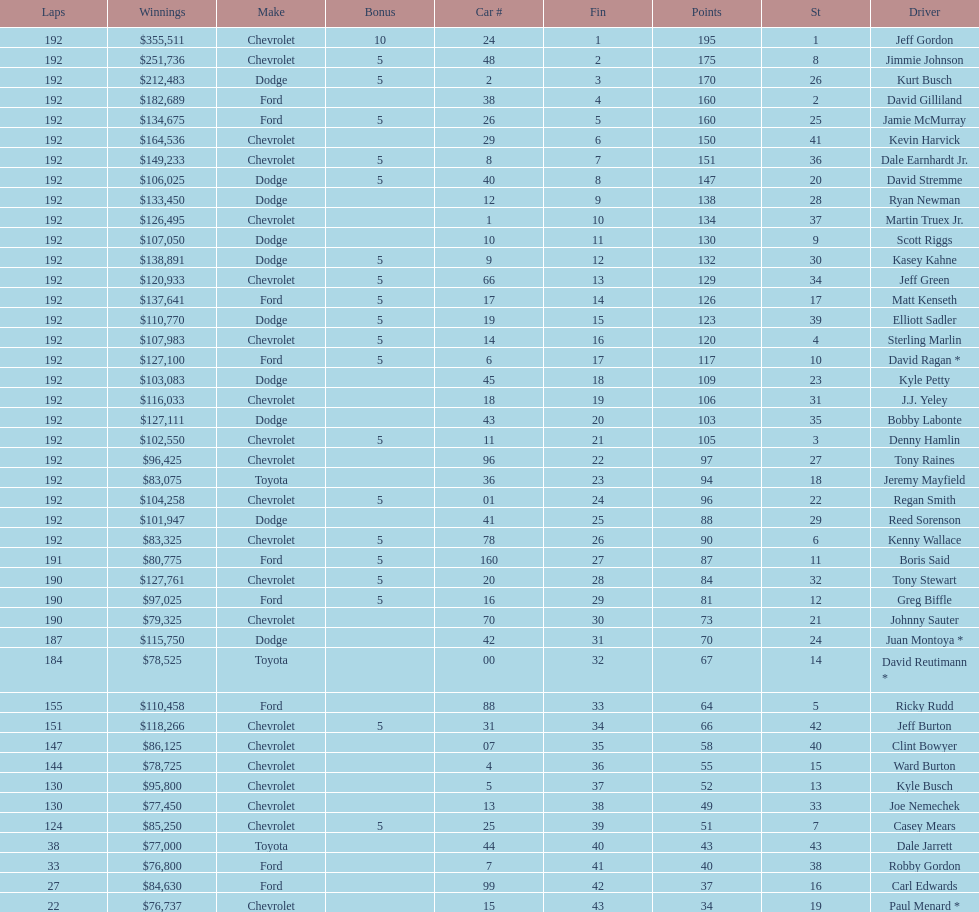What make did kurt busch drive? Dodge. 